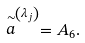<formula> <loc_0><loc_0><loc_500><loc_500>\stackrel { \sim } { a } ^ { \left ( \lambda _ { j } \right ) } = A _ { 6 } .</formula> 